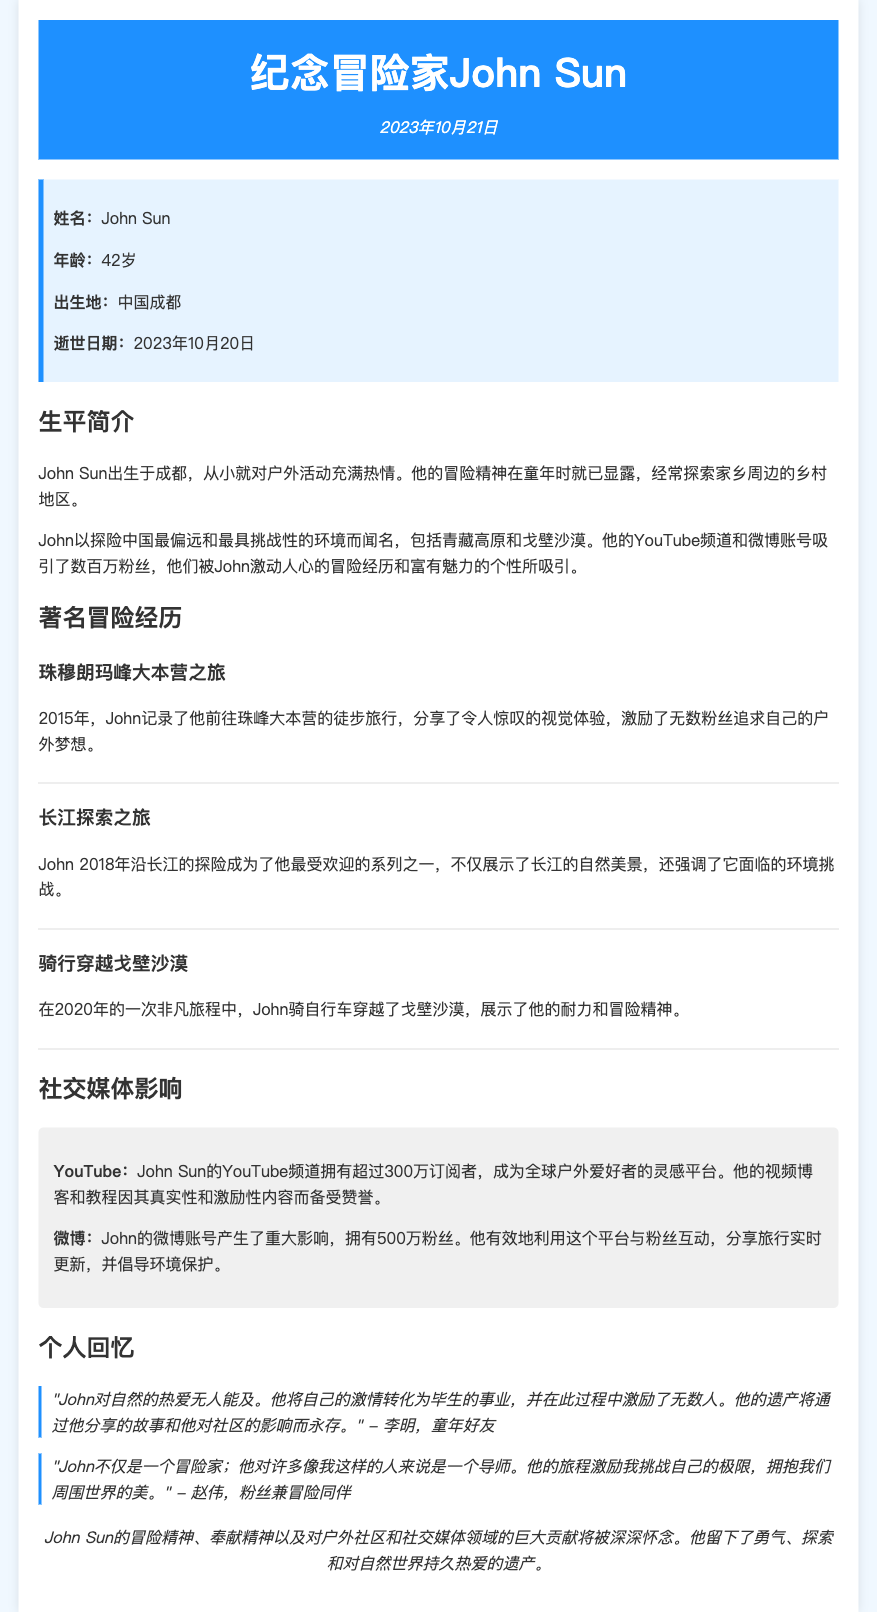姓名是什么？ 这是文档中提到的主要人物的名字。
Answer: John Sun John Sun的年龄是多少？ 文档中明确指出了John的年龄。
Answer: 42岁 John Sun的出生地在哪里？ 这是John Sun的出生地点。
Answer: 中国成都 他去世的日期是什么时候？ 文档中提供了John Sun的去世日期。
Answer: 2023年10月20日 John Sun最受欢迎的冒险经历是什么？ 这是文档中提到的John的著名冒险之一。
Answer: 长江探索之旅 John Sun的YouTube频道有多少个订阅者？ 文档中说明了他在YouTube上的订阅者数量。
Answer: 超过300万 John Sun在微博上的粉丝数量是多少？ 这是文档中提到的他在社交媒体上的影响力表现。
Answer: 500万 文档中的哪个人对John Sun的影响进行了描述？ 文档中引用的人是对John的影响进行评价的。
Answer: 李明 John Sun的遗产主要通过什么方式延续？ 文档中提到的John的遗产延续的方式。
Answer: 他分享的故事 